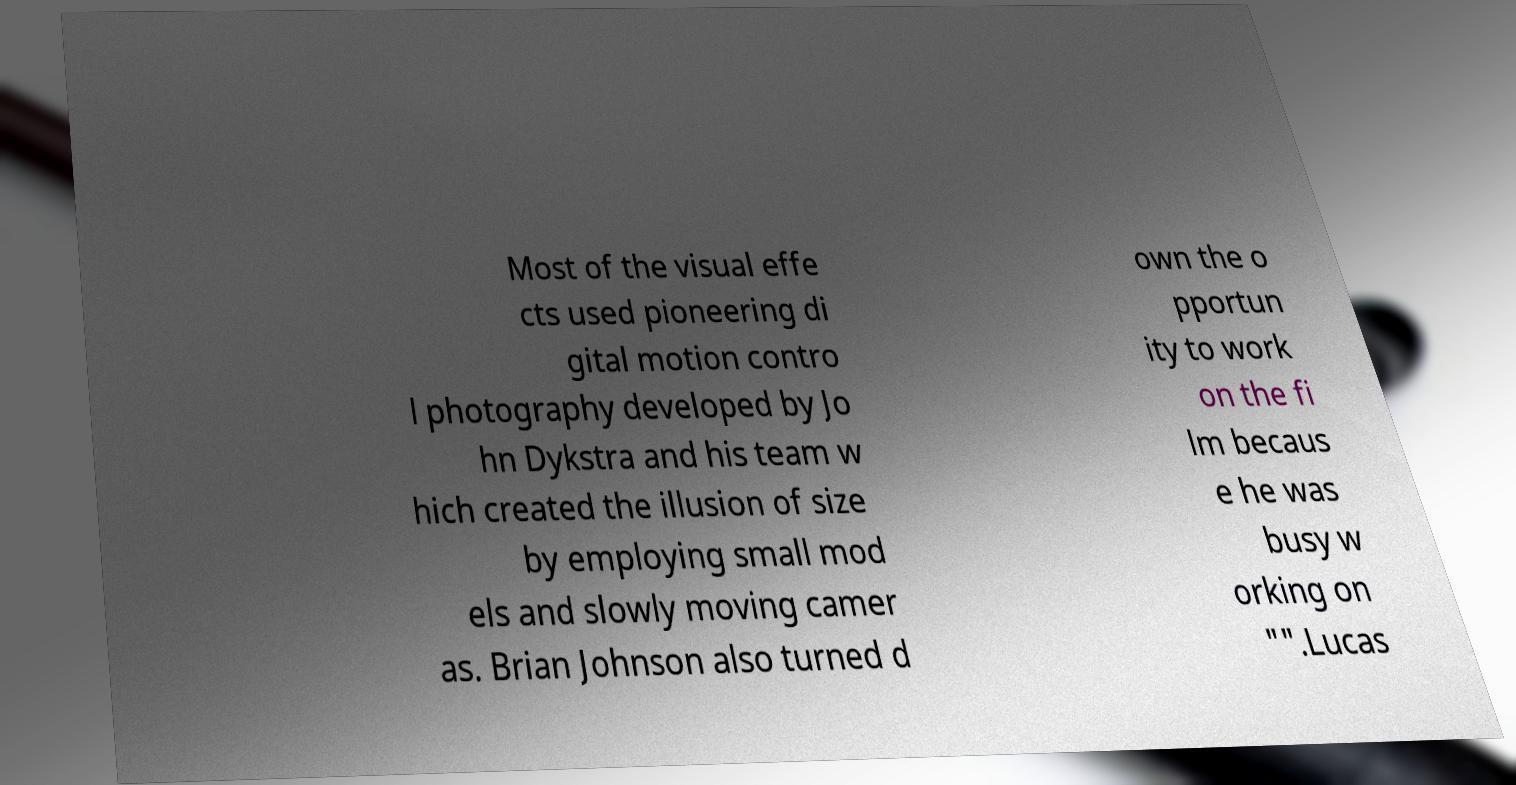What messages or text are displayed in this image? I need them in a readable, typed format. Most of the visual effe cts used pioneering di gital motion contro l photography developed by Jo hn Dykstra and his team w hich created the illusion of size by employing small mod els and slowly moving camer as. Brian Johnson also turned d own the o pportun ity to work on the fi lm becaus e he was busy w orking on "".Lucas 